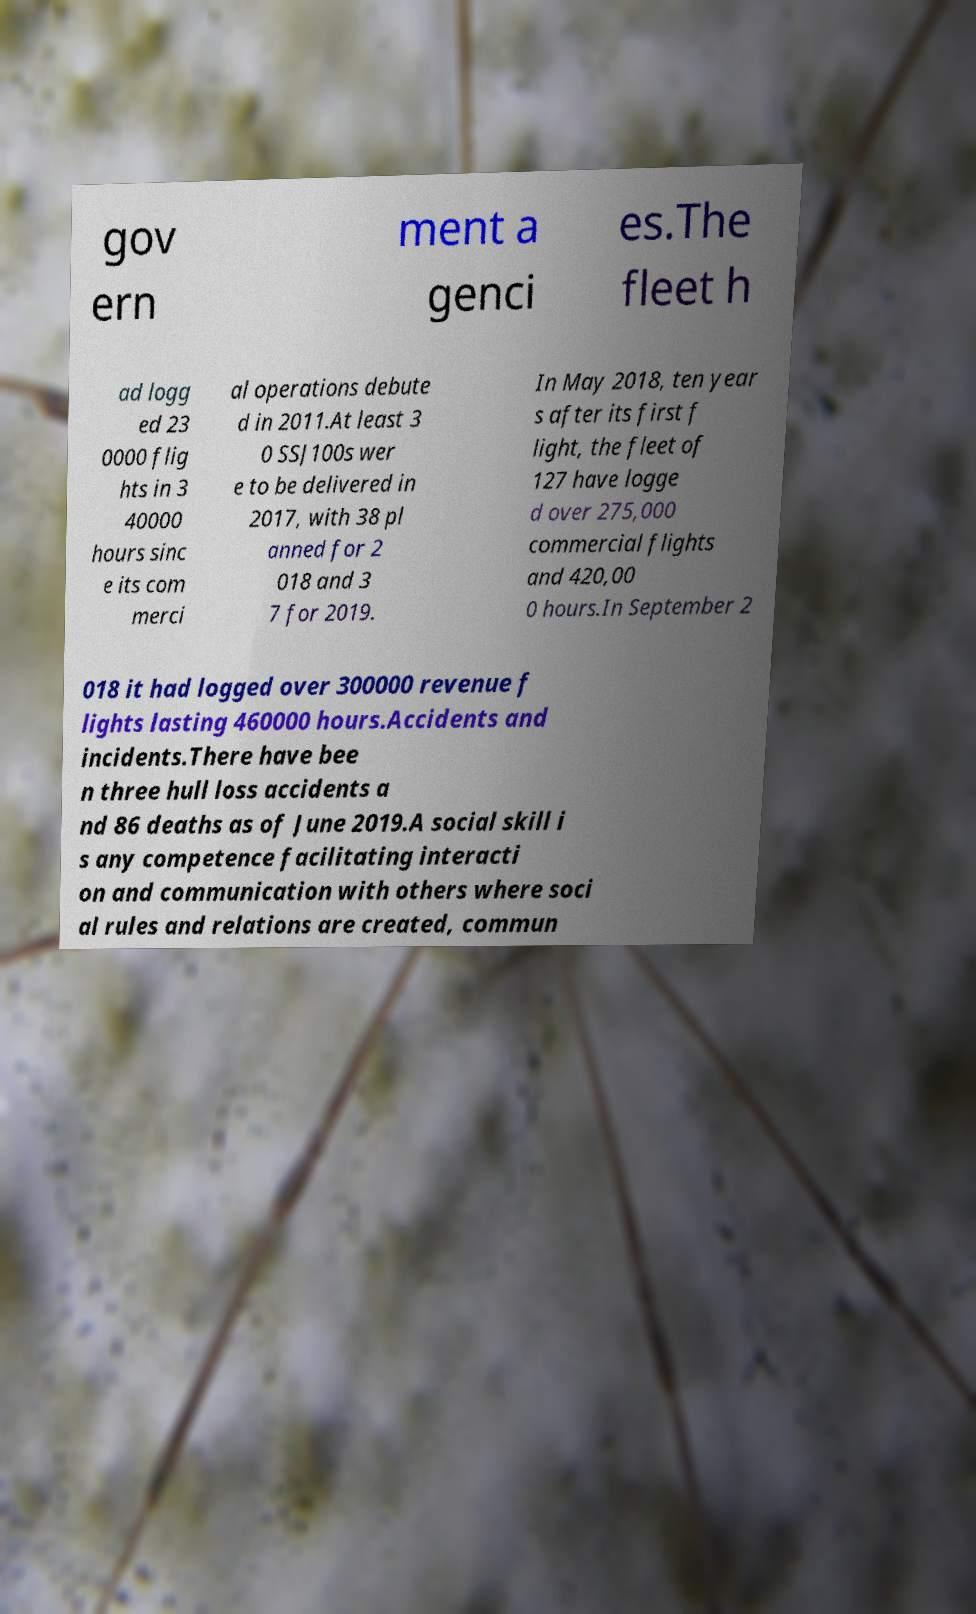Please identify and transcribe the text found in this image. gov ern ment a genci es.The fleet h ad logg ed 23 0000 flig hts in 3 40000 hours sinc e its com merci al operations debute d in 2011.At least 3 0 SSJ100s wer e to be delivered in 2017, with 38 pl anned for 2 018 and 3 7 for 2019. In May 2018, ten year s after its first f light, the fleet of 127 have logge d over 275,000 commercial flights and 420,00 0 hours.In September 2 018 it had logged over 300000 revenue f lights lasting 460000 hours.Accidents and incidents.There have bee n three hull loss accidents a nd 86 deaths as of June 2019.A social skill i s any competence facilitating interacti on and communication with others where soci al rules and relations are created, commun 